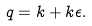<formula> <loc_0><loc_0><loc_500><loc_500>q = k + k \epsilon .</formula> 